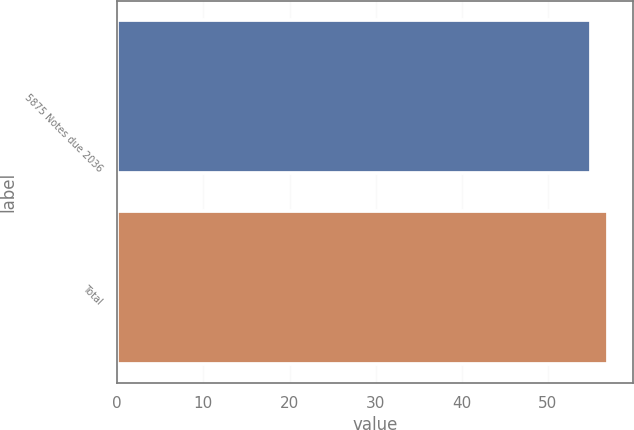Convert chart to OTSL. <chart><loc_0><loc_0><loc_500><loc_500><bar_chart><fcel>5875 Notes due 2036<fcel>Total<nl><fcel>55<fcel>57<nl></chart> 